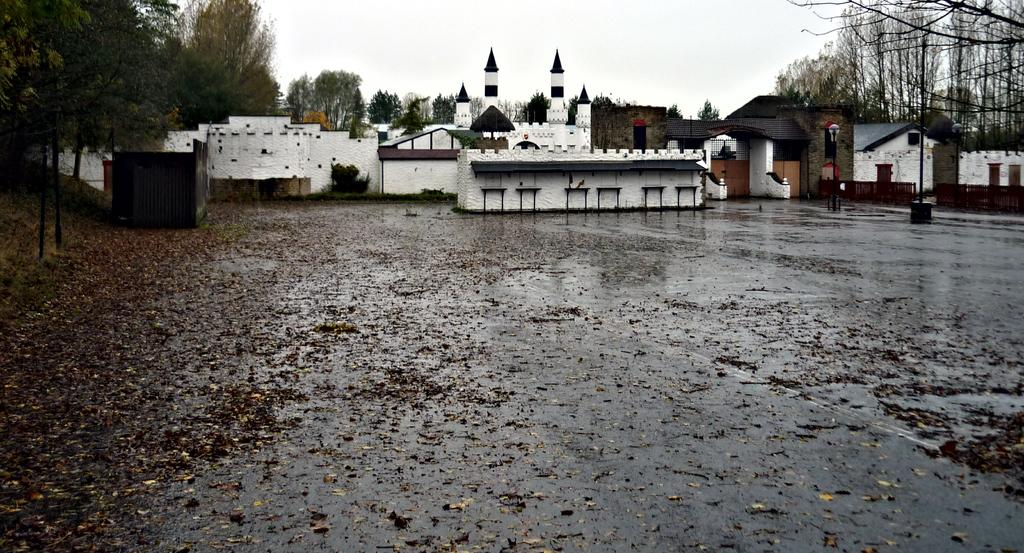What type of structures can be seen in the image? There are buildings in the image. What type of vegetation is present in the image? There are trees in the image. What is covering the ground in the image? The ground is covered with dry leaves. What type of tooth can be seen growing on the tree in the image? There are no teeth present in the image, as it features buildings, trees, and dry leaves on the ground. 